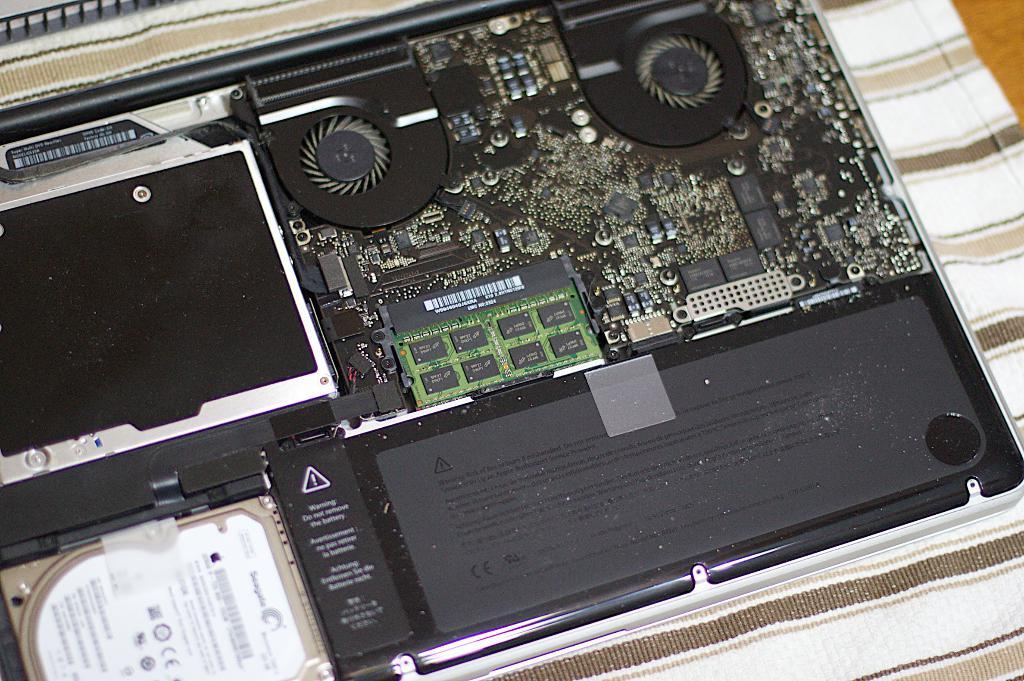<image>
Offer a succinct explanation of the picture presented. The hard drive in the computer is from Seagate 